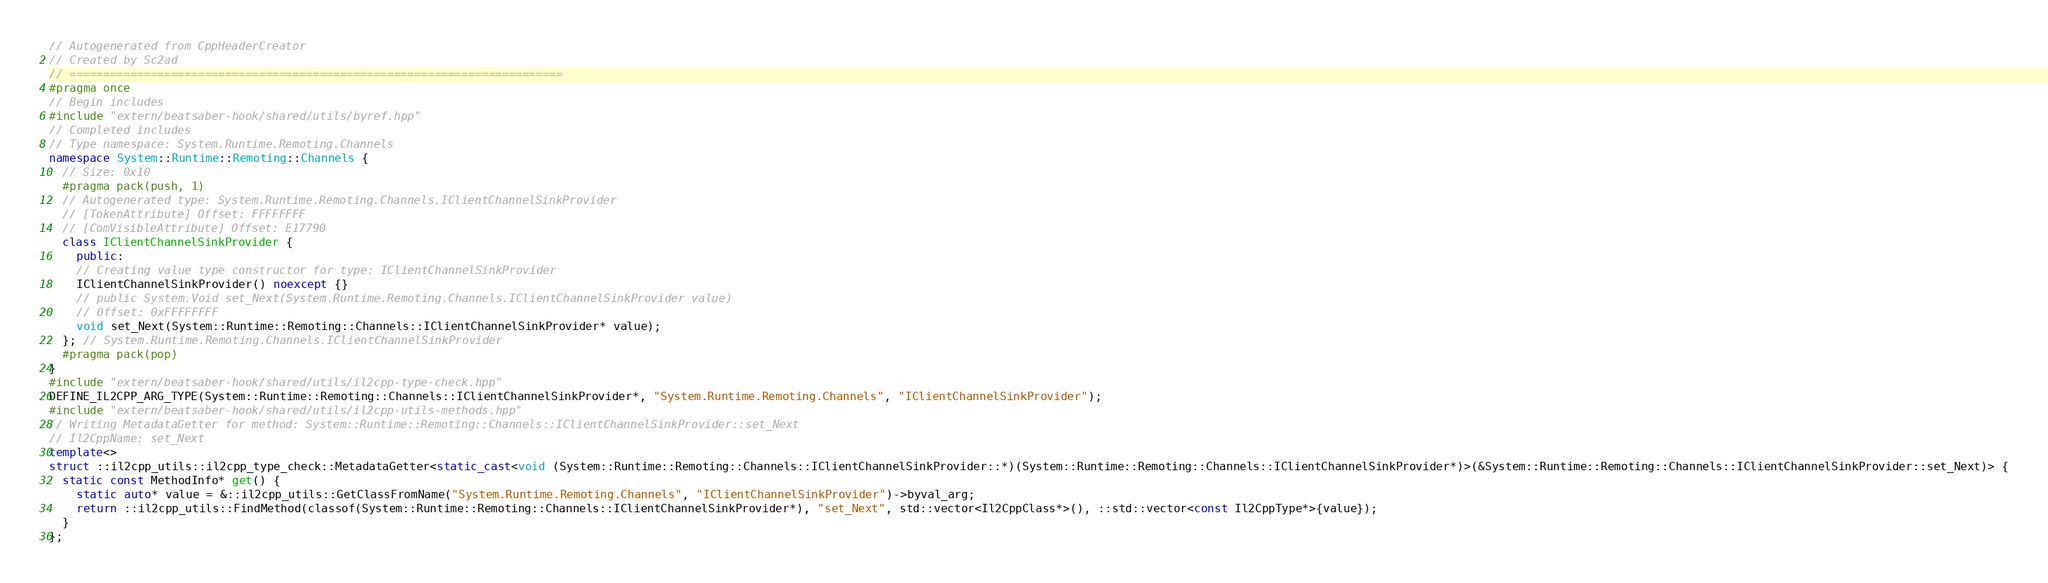<code> <loc_0><loc_0><loc_500><loc_500><_C++_>// Autogenerated from CppHeaderCreator
// Created by Sc2ad
// =========================================================================
#pragma once
// Begin includes
#include "extern/beatsaber-hook/shared/utils/byref.hpp"
// Completed includes
// Type namespace: System.Runtime.Remoting.Channels
namespace System::Runtime::Remoting::Channels {
  // Size: 0x10
  #pragma pack(push, 1)
  // Autogenerated type: System.Runtime.Remoting.Channels.IClientChannelSinkProvider
  // [TokenAttribute] Offset: FFFFFFFF
  // [ComVisibleAttribute] Offset: E17790
  class IClientChannelSinkProvider {
    public:
    // Creating value type constructor for type: IClientChannelSinkProvider
    IClientChannelSinkProvider() noexcept {}
    // public System.Void set_Next(System.Runtime.Remoting.Channels.IClientChannelSinkProvider value)
    // Offset: 0xFFFFFFFF
    void set_Next(System::Runtime::Remoting::Channels::IClientChannelSinkProvider* value);
  }; // System.Runtime.Remoting.Channels.IClientChannelSinkProvider
  #pragma pack(pop)
}
#include "extern/beatsaber-hook/shared/utils/il2cpp-type-check.hpp"
DEFINE_IL2CPP_ARG_TYPE(System::Runtime::Remoting::Channels::IClientChannelSinkProvider*, "System.Runtime.Remoting.Channels", "IClientChannelSinkProvider");
#include "extern/beatsaber-hook/shared/utils/il2cpp-utils-methods.hpp"
// Writing MetadataGetter for method: System::Runtime::Remoting::Channels::IClientChannelSinkProvider::set_Next
// Il2CppName: set_Next
template<>
struct ::il2cpp_utils::il2cpp_type_check::MetadataGetter<static_cast<void (System::Runtime::Remoting::Channels::IClientChannelSinkProvider::*)(System::Runtime::Remoting::Channels::IClientChannelSinkProvider*)>(&System::Runtime::Remoting::Channels::IClientChannelSinkProvider::set_Next)> {
  static const MethodInfo* get() {
    static auto* value = &::il2cpp_utils::GetClassFromName("System.Runtime.Remoting.Channels", "IClientChannelSinkProvider")->byval_arg;
    return ::il2cpp_utils::FindMethod(classof(System::Runtime::Remoting::Channels::IClientChannelSinkProvider*), "set_Next", std::vector<Il2CppClass*>(), ::std::vector<const Il2CppType*>{value});
  }
};
</code> 